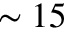<formula> <loc_0><loc_0><loc_500><loc_500>\sim 1 5</formula> 